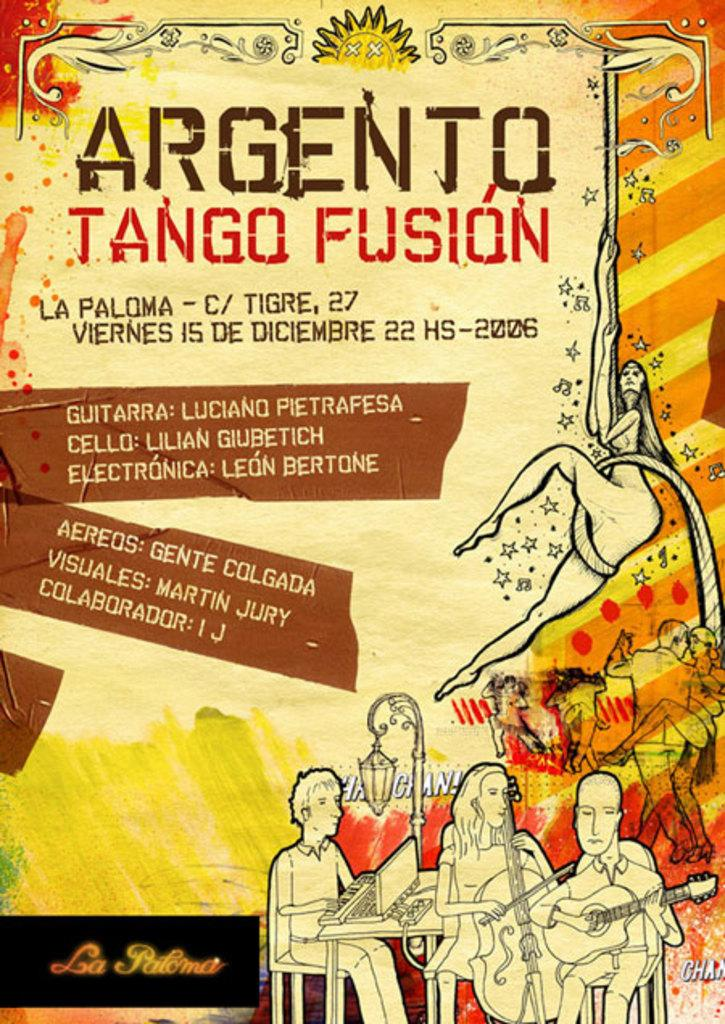<image>
Provide a brief description of the given image. A colorful poster announcing the Argento Tango Fusion. 